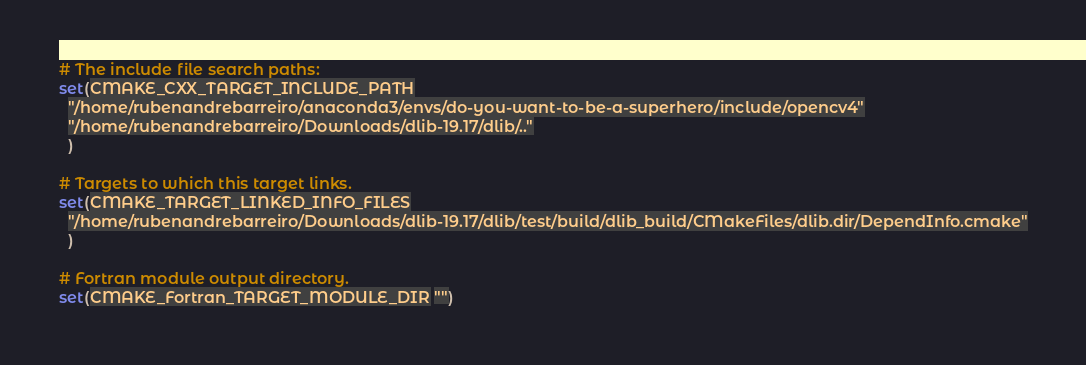<code> <loc_0><loc_0><loc_500><loc_500><_CMake_>
# The include file search paths:
set(CMAKE_CXX_TARGET_INCLUDE_PATH
  "/home/rubenandrebarreiro/anaconda3/envs/do-you-want-to-be-a-superhero/include/opencv4"
  "/home/rubenandrebarreiro/Downloads/dlib-19.17/dlib/.."
  )

# Targets to which this target links.
set(CMAKE_TARGET_LINKED_INFO_FILES
  "/home/rubenandrebarreiro/Downloads/dlib-19.17/dlib/test/build/dlib_build/CMakeFiles/dlib.dir/DependInfo.cmake"
  )

# Fortran module output directory.
set(CMAKE_Fortran_TARGET_MODULE_DIR "")
</code> 